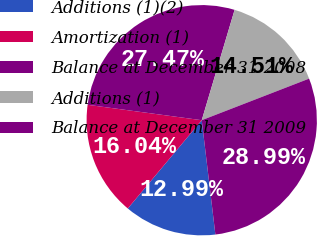<chart> <loc_0><loc_0><loc_500><loc_500><pie_chart><fcel>Additions (1)(2)<fcel>Amortization (1)<fcel>Balance at December 31 2008<fcel>Additions (1)<fcel>Balance at December 31 2009<nl><fcel>12.99%<fcel>16.04%<fcel>27.47%<fcel>14.51%<fcel>28.99%<nl></chart> 